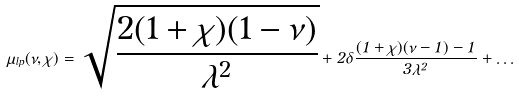Convert formula to latex. <formula><loc_0><loc_0><loc_500><loc_500>\hat { \mu } _ { l p } ( \nu , \chi ) = \sqrt { \frac { 2 ( 1 + \chi ) ( 1 - \nu ) } { \lambda ^ { 2 } } } + 2 \delta \frac { ( 1 + \chi ) ( \nu - 1 ) - 1 } { 3 \lambda ^ { 2 } } + \dots</formula> 